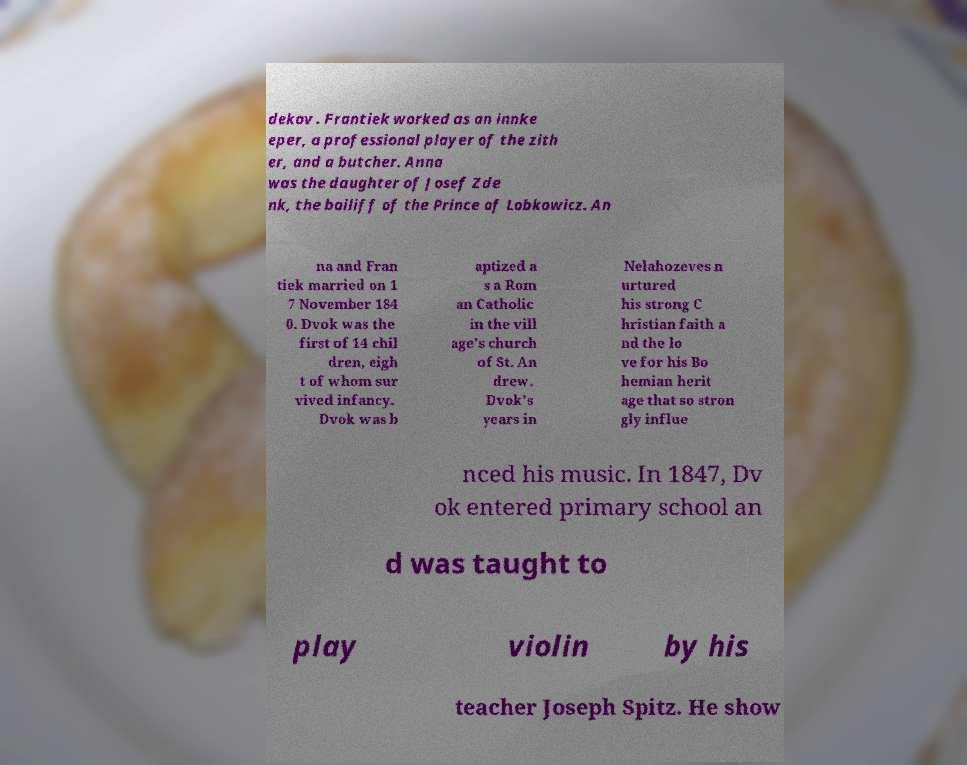What messages or text are displayed in this image? I need them in a readable, typed format. dekov . Frantiek worked as an innke eper, a professional player of the zith er, and a butcher. Anna was the daughter of Josef Zde nk, the bailiff of the Prince of Lobkowicz. An na and Fran tiek married on 1 7 November 184 0. Dvok was the first of 14 chil dren, eigh t of whom sur vived infancy. Dvok was b aptized a s a Rom an Catholic in the vill age's church of St. An drew. Dvok's years in Nelahozeves n urtured his strong C hristian faith a nd the lo ve for his Bo hemian herit age that so stron gly influe nced his music. In 1847, Dv ok entered primary school an d was taught to play violin by his teacher Joseph Spitz. He show 